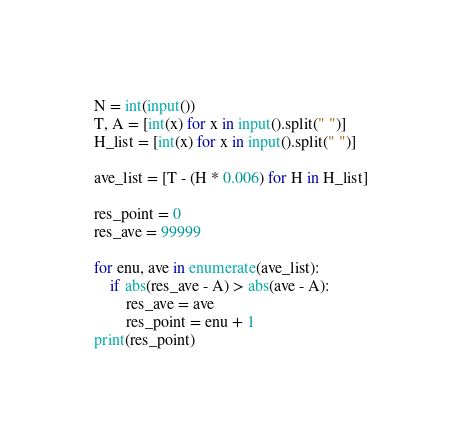<code> <loc_0><loc_0><loc_500><loc_500><_Python_>N = int(input())
T, A = [int(x) for x in input().split(" ")]
H_list = [int(x) for x in input().split(" ")]

ave_list = [T - (H * 0.006) for H in H_list]

res_point = 0
res_ave = 99999

for enu, ave in enumerate(ave_list):
    if abs(res_ave - A) > abs(ave - A):
        res_ave = ave
        res_point = enu + 1
print(res_point)
</code> 